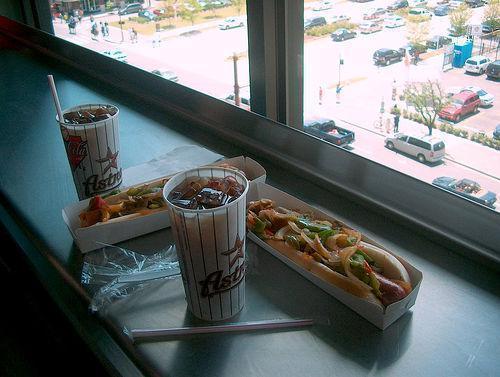What food is shown in the boats?
Pick the correct solution from the four options below to address the question.
Options: Pizza, hot dog, hamburger, tacos. Hot dog. 